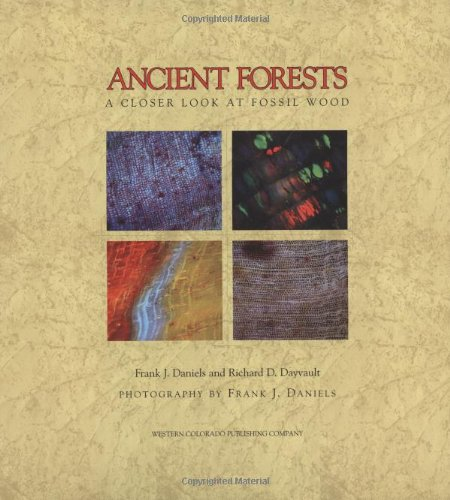What techniques did the photographer use to capture the details in these ancient woods? Frank J. Daniels, who is also a co-author, utilized macro-photography techniques to capture the intricate details of the fossilized wood. His approach often involves careful lighting and high-resolution cameras to reveal the subtle textures and patterns that normal photography might miss, which beautifully highlight the ancient wood's structure and its transformation over time. 